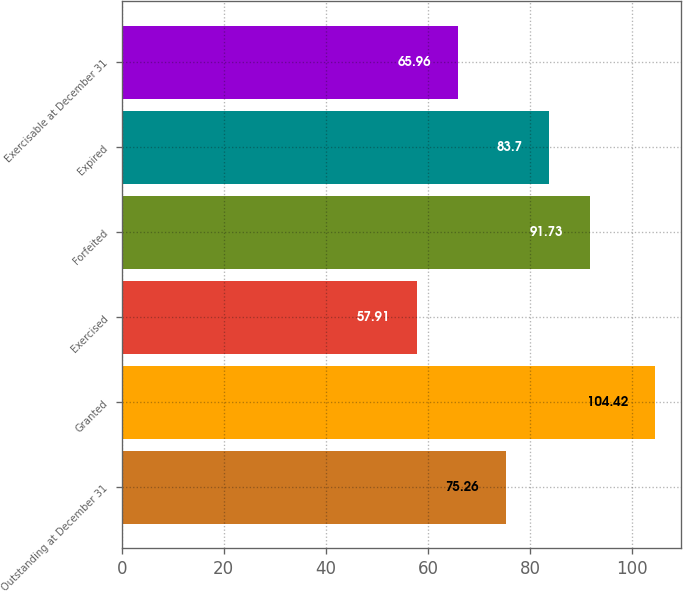Convert chart. <chart><loc_0><loc_0><loc_500><loc_500><bar_chart><fcel>Outstanding at December 31<fcel>Granted<fcel>Exercised<fcel>Forfeited<fcel>Expired<fcel>Exercisable at December 31<nl><fcel>75.26<fcel>104.42<fcel>57.91<fcel>91.73<fcel>83.7<fcel>65.96<nl></chart> 